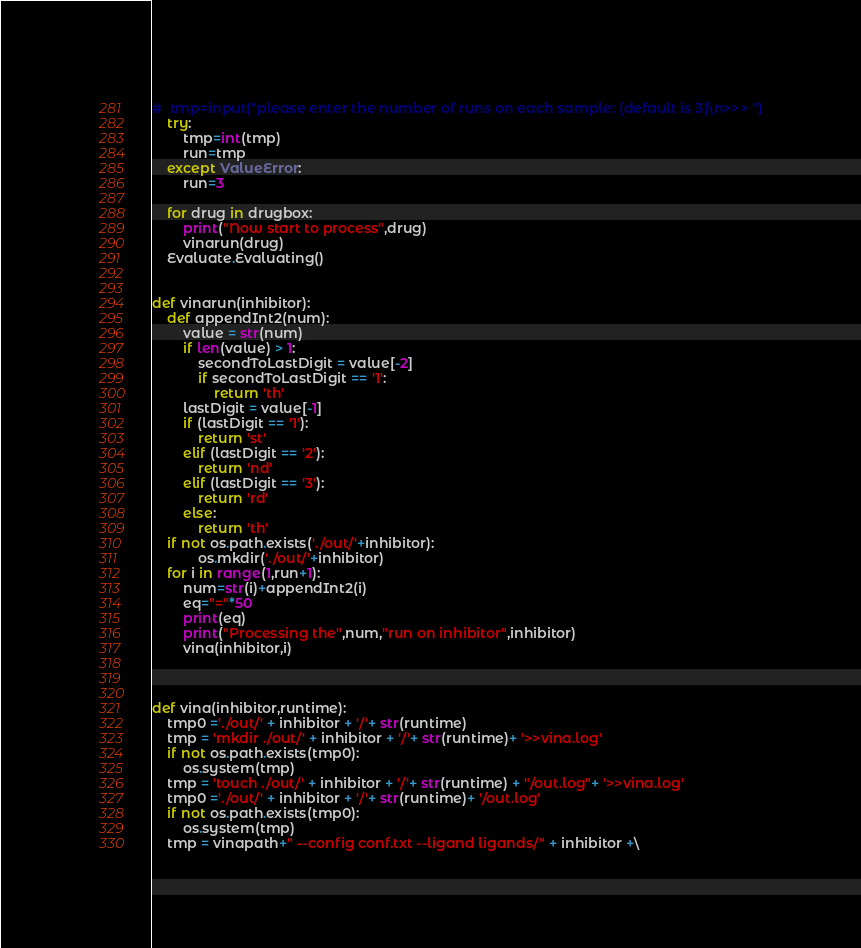Convert code to text. <code><loc_0><loc_0><loc_500><loc_500><_Python_>#  tmp=input("please enter the number of runs on each sample: (default is 3)\n>>> ")
    try:
        tmp=int(tmp)
        run=tmp
    except ValueError:
        run=3

    for drug in drugbox:
        print("Now start to process",drug)
        vinarun(drug)
    Evaluate.Evaluating()


def vinarun(inhibitor):
    def appendInt2(num):
        value = str(num)
        if len(value) > 1:
            secondToLastDigit = value[-2]
            if secondToLastDigit == '1':
                return 'th'
        lastDigit = value[-1]
        if (lastDigit == '1'):
            return 'st'
        elif (lastDigit == '2'):
            return 'nd'
        elif (lastDigit == '3'):
            return 'rd'
        else:
            return 'th'
    if not os.path.exists('./out/'+inhibitor):
            os.mkdir('./out/'+inhibitor)
    for i in range(1,run+1):
        num=str(i)+appendInt2(i)
        eq="="*50
        print(eq)
        print("Processing the",num,"run on inhibitor",inhibitor)
        vina(inhibitor,i)



def vina(inhibitor,runtime):
    tmp0 ='./out/' + inhibitor + '/'+ str(runtime)
    tmp = 'mkdir ./out/' + inhibitor + '/'+ str(runtime)+ '>>vina.log'
    if not os.path.exists(tmp0):
        os.system(tmp)
    tmp = 'touch ./out/' + inhibitor + '/'+ str(runtime) + "/out.log"+ '>>vina.log'
    tmp0 ='./out/' + inhibitor + '/'+ str(runtime)+ '/out.log'
    if not os.path.exists(tmp0):
        os.system(tmp)
    tmp = vinapath+" --config conf.txt --ligand ligands/" + inhibitor +\</code> 